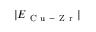<formula> <loc_0><loc_0><loc_500><loc_500>| E _ { C u - Z r } |</formula> 